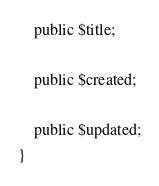Convert code to text. <code><loc_0><loc_0><loc_500><loc_500><_PHP_>    public $title;

    public $created;

    public $updated;
} </code> 